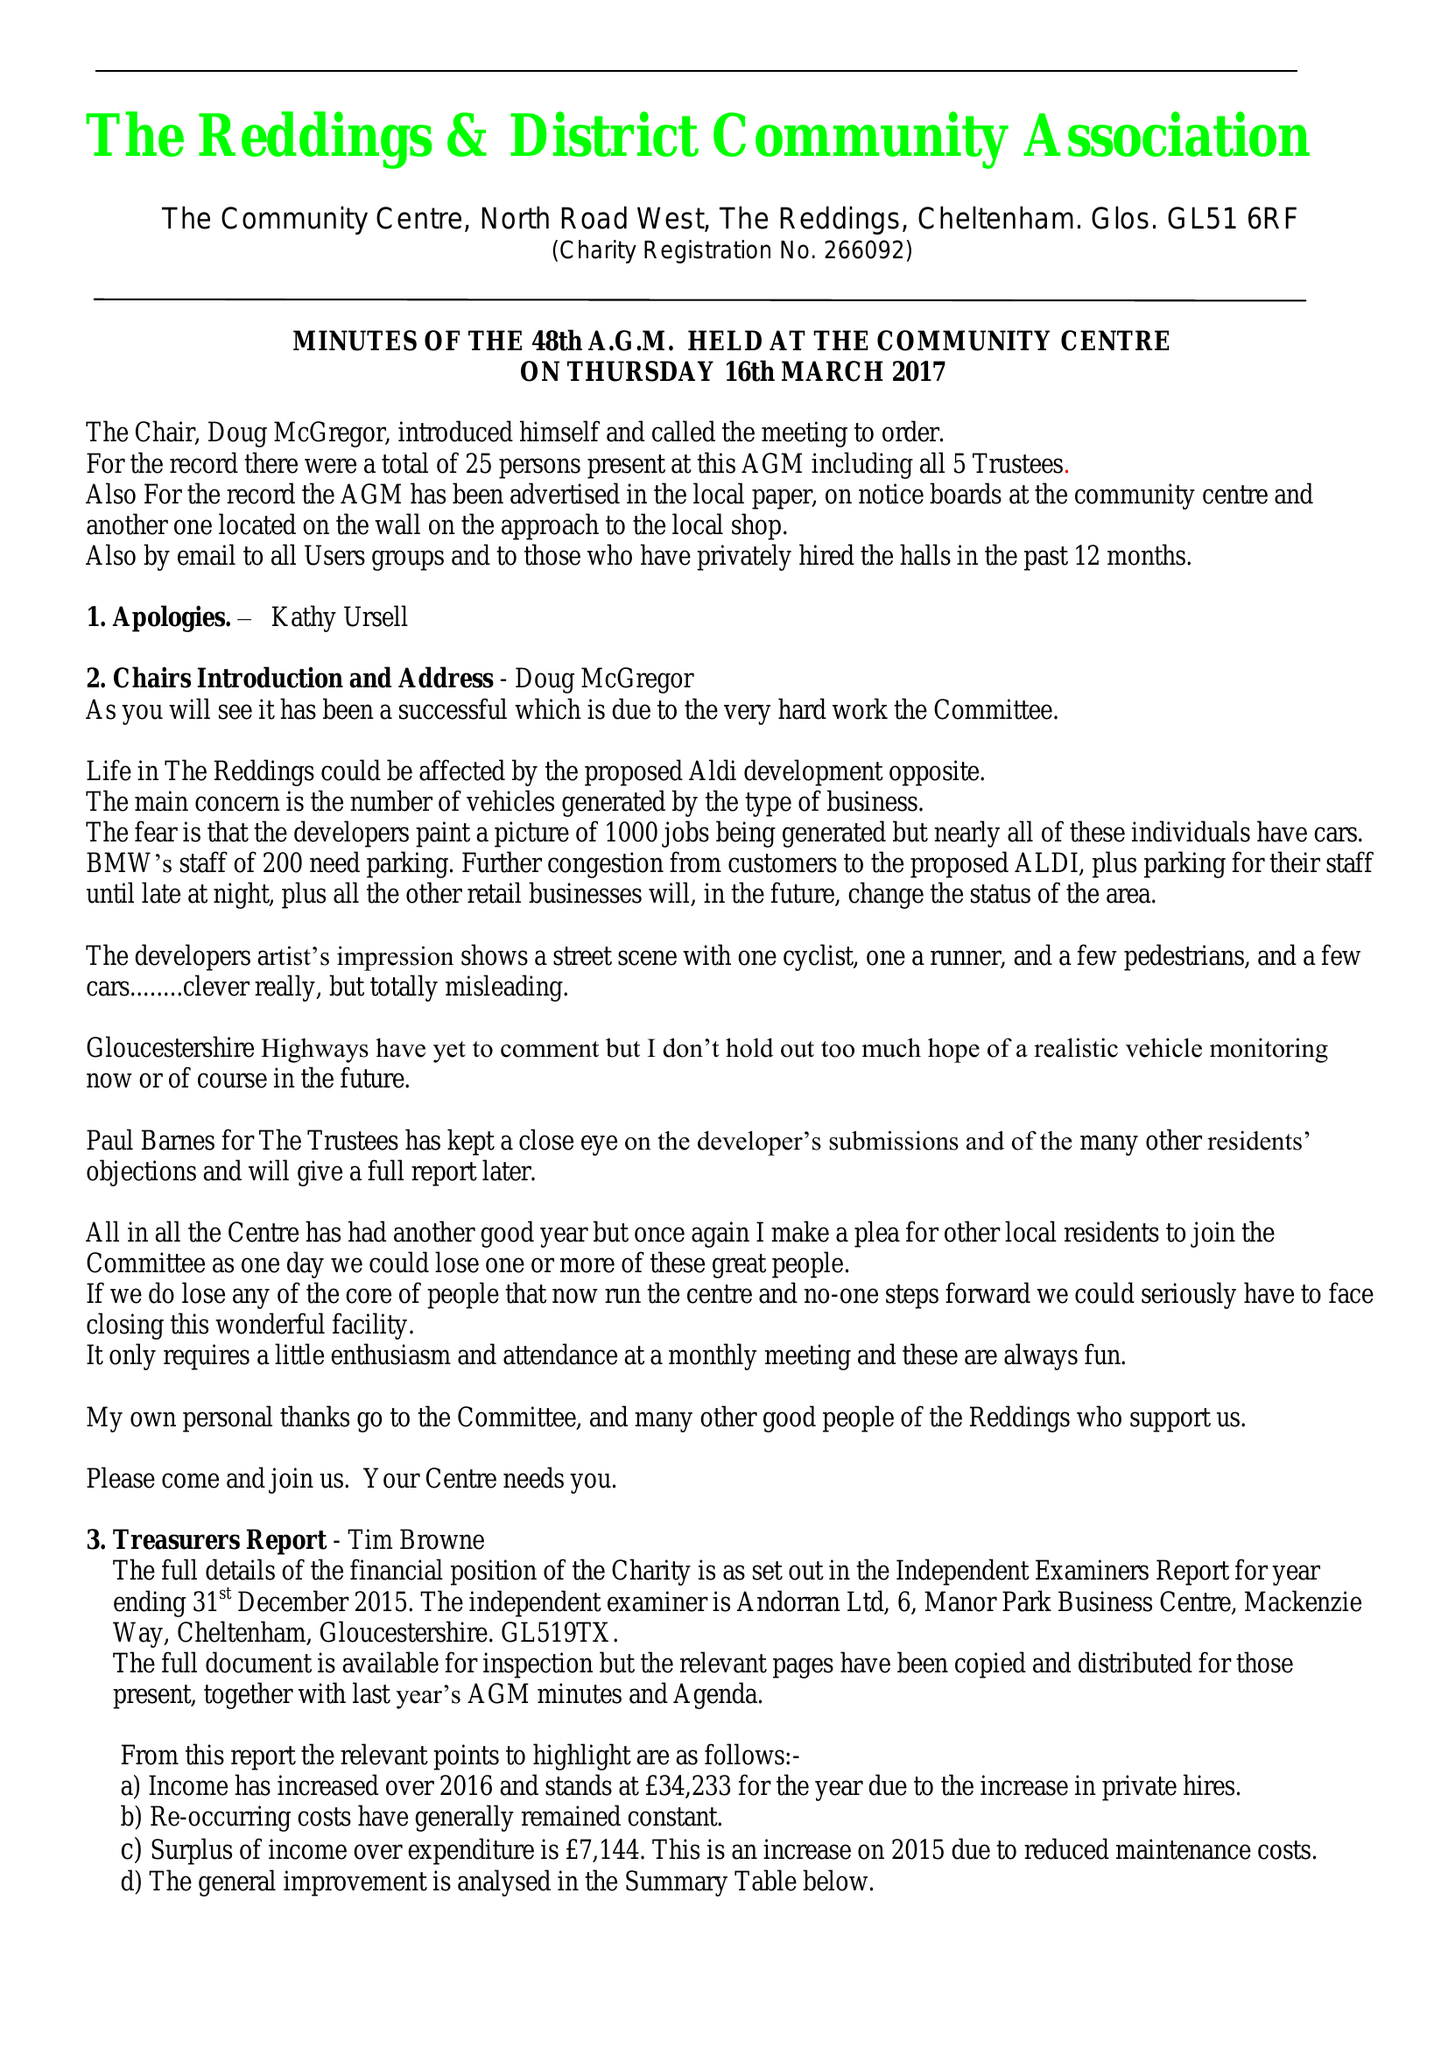What is the value for the address__post_town?
Answer the question using a single word or phrase. CHELTENHAM 